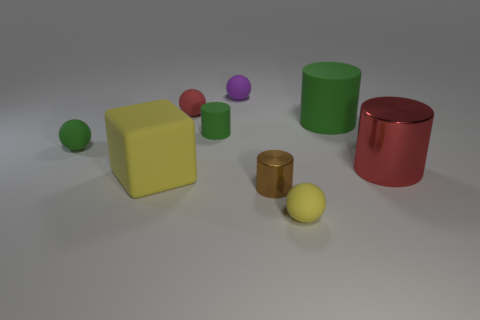Are there any green matte spheres to the left of the small sphere that is in front of the red thing that is in front of the small red thing? Indeed, to the left of the small sphere, which is in front of the larger red cylindrical object, and consequently in front of the smaller red cylinder, there is one green matte sphere. 